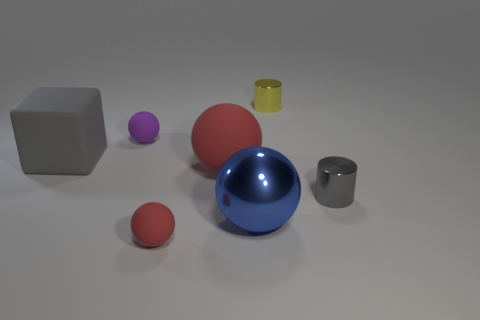What is the material of the gray object that is to the right of the red rubber object in front of the tiny cylinder in front of the big red rubber sphere?
Provide a succinct answer. Metal. Is the number of big red balls to the left of the big gray cube the same as the number of tiny gray rubber spheres?
Your response must be concise. Yes. Are the small ball behind the large blue shiny sphere and the tiny sphere that is in front of the gray cube made of the same material?
Your answer should be very brief. Yes. There is a big red matte object to the left of the tiny gray metallic cylinder; is its shape the same as the rubber object that is behind the cube?
Offer a very short reply. Yes. Is the number of purple spheres that are right of the tiny yellow shiny object less than the number of purple balls?
Give a very brief answer. Yes. How many things are the same color as the big matte block?
Make the answer very short. 1. How big is the rubber object left of the small purple matte sphere?
Keep it short and to the point. Large. What is the shape of the gray thing that is behind the red matte ball behind the small rubber object in front of the large gray thing?
Keep it short and to the point. Cube. The thing that is both left of the blue sphere and in front of the small gray cylinder has what shape?
Offer a terse response. Sphere. Are there any blue objects that have the same size as the yellow metallic object?
Make the answer very short. No. 